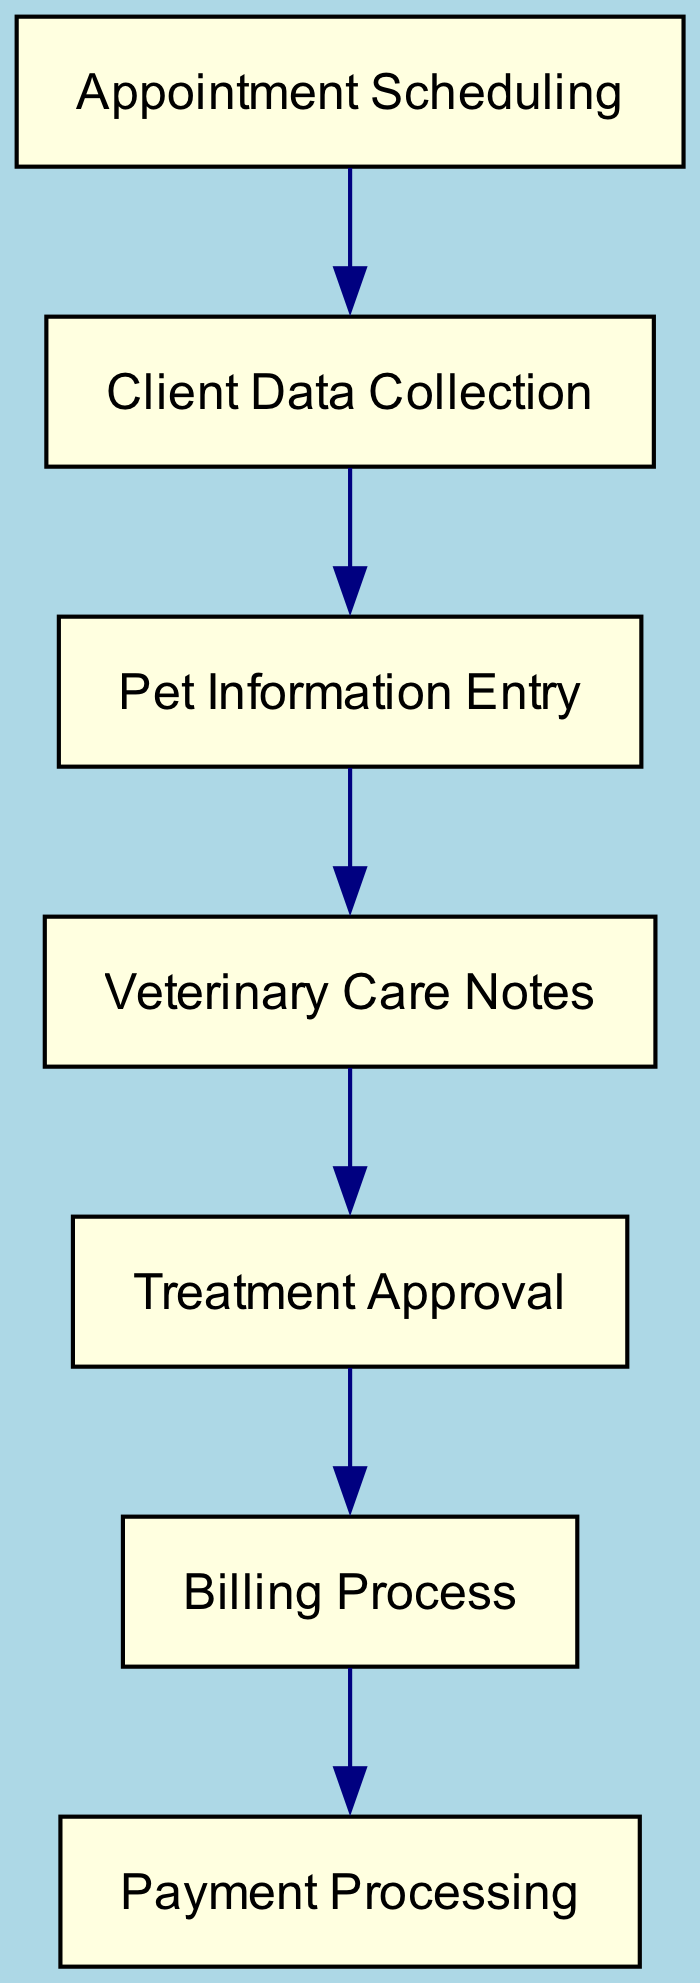What is the first step in the workflow? The diagram starts with the node "Appointment Scheduling," indicating that this is the first step taken in the workflow process.
Answer: Appointment Scheduling How many nodes are in this directed graph? By counting all unique nodes listed in the diagram, there are a total of 7 nodes: Appointment Scheduling, Client Data Collection, Pet Information Entry, Veterinary Care Notes, Treatment Approval, Billing Process, and Payment Processing.
Answer: 7 Which node follows the "Veterinary Care Notes" node? The directed edge from "Veterinary Care Notes" indicates that the next step in the workflow proceeds to the "Treatment Approval" node.
Answer: Treatment Approval What is the last step in the workflow? The flow of the diagram concludes with the node "Payment Processing," which is indicated as the final node following the "Billing Process."
Answer: Payment Processing How many edges are there in the graph? By examining the connections (edges) between the nodes, we see there are a total of 6 edges that indicate the flow from one node to the next.
Answer: 6 What two nodes are directly connected to the "Billing Process"? The "Billing Process" node is connected by a directed edge to "Treatment Approval" and subsequently to "Payment Processing," indicating the flow in this direction.
Answer: Treatment Approval, Payment Processing What is the relationship between "Client Data Collection" and "Pet Information Entry"? According to the directed graph, "Client Data Collection" flows into "Pet Information Entry," meaning that after client data is collected, it leads to the entry of pet information.
Answer: Client Data Collection leads to Pet Information Entry Which node has no outgoing edges? The "Payment Processing" node does not have any outgoing edges, indicating that it is the final point in this workflow.
Answer: Payment Processing 